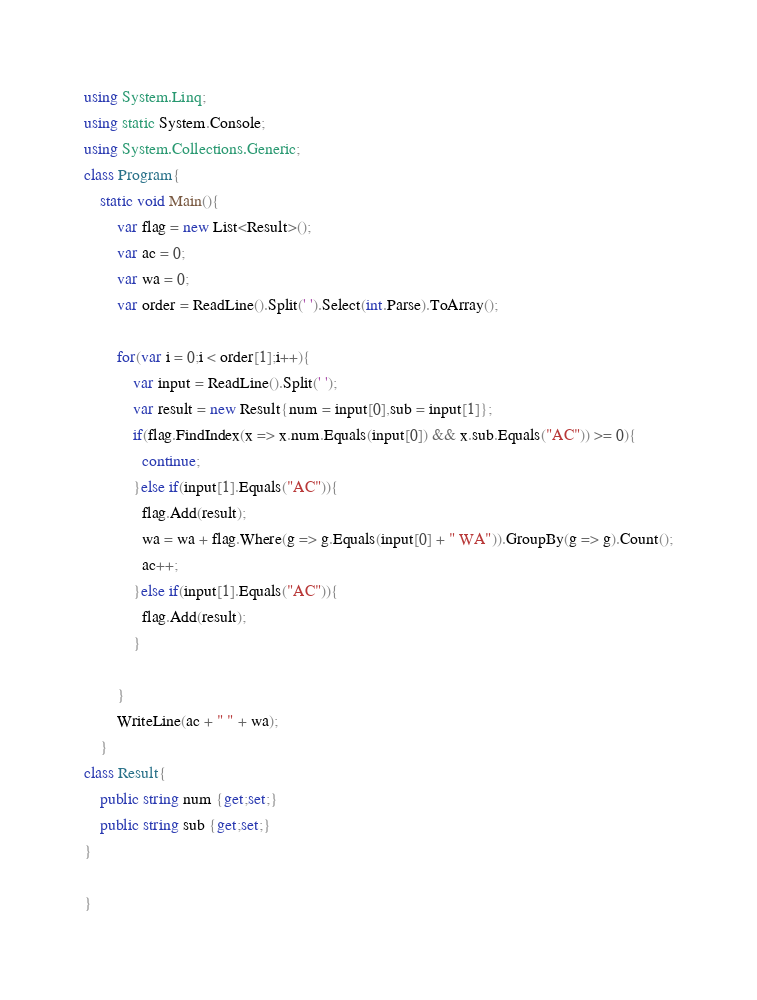<code> <loc_0><loc_0><loc_500><loc_500><_C#_>using System.Linq;
using static System.Console;
using System.Collections.Generic;
class Program{
	static void Main(){
		var flag = new List<Result>();
        var ac = 0;
        var wa = 0;
        var order = ReadLine().Split(' ').Select(int.Parse).ToArray();
        
      	for(var i = 0;i < order[1];i++){
        	var input = ReadLine().Split(' ');
          	var result = new Result{num = input[0],sub = input[1]};
          	if(flag.FindIndex(x => x.num.Equals(input[0]) && x.sub.Equals("AC")) >= 0){
              continue;
            }else if(input[1].Equals("AC")){
           	  flag.Add(result);
              wa = wa + flag.Where(g => g.Equals(input[0] + " WA")).GroupBy(g => g).Count();
              ac++;
            }else if(input[1].Equals("AC")){
              flag.Add(result);
            }

        }
        WriteLine(ac + " " + wa);
    }
class Result{
	public string num {get;set;}
  	public string sub {get;set;}
}  
  
}
</code> 